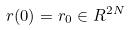Convert formula to latex. <formula><loc_0><loc_0><loc_500><loc_500>r ( 0 ) = r _ { 0 } \in R ^ { 2 N }</formula> 